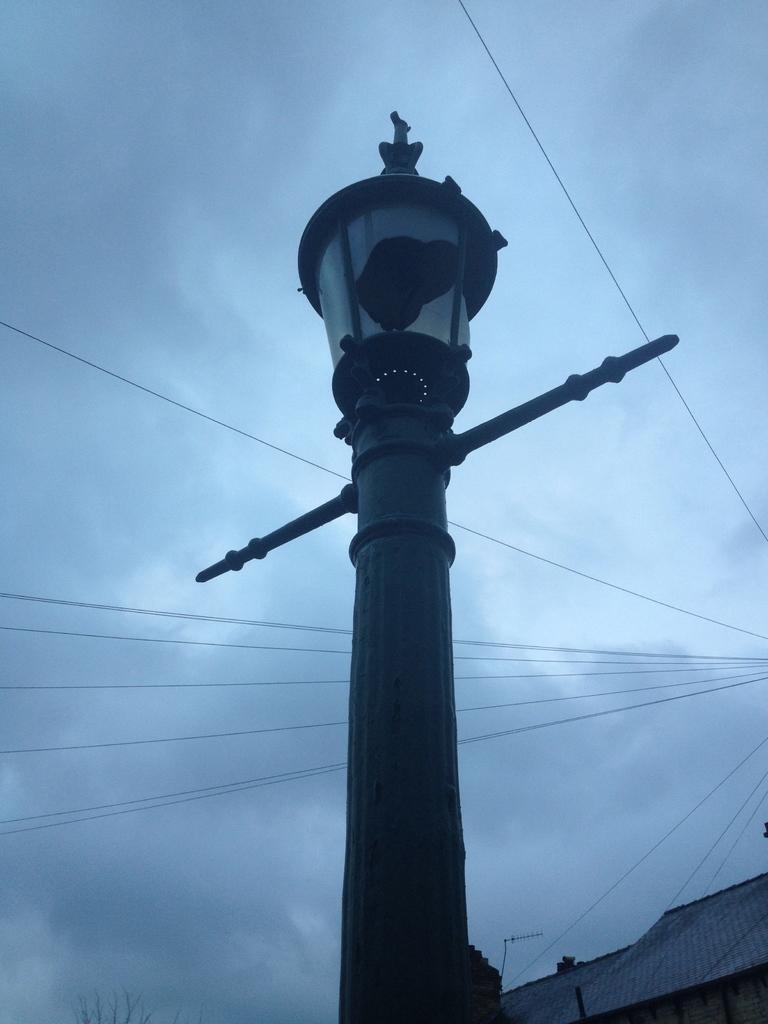Describe this image in one or two sentences. In the center of the image we can see a pole, light. At the bottom of the image we can see the roof, tree, wall. In the background of the image the wires, clouds in the sky. 